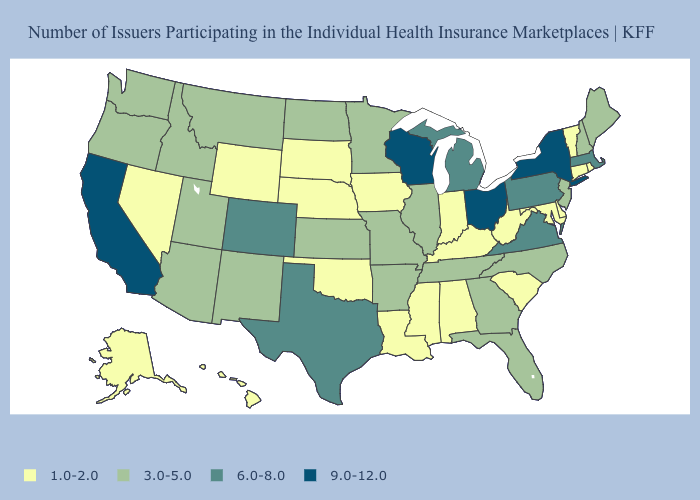What is the value of Missouri?
Concise answer only. 3.0-5.0. Among the states that border New Hampshire , does Massachusetts have the highest value?
Be succinct. Yes. How many symbols are there in the legend?
Answer briefly. 4. What is the highest value in the USA?
Write a very short answer. 9.0-12.0. What is the lowest value in the USA?
Write a very short answer. 1.0-2.0. How many symbols are there in the legend?
Give a very brief answer. 4. What is the value of South Carolina?
Quick response, please. 1.0-2.0. Does Maine have the highest value in the Northeast?
Be succinct. No. Which states have the lowest value in the USA?
Concise answer only. Alabama, Alaska, Connecticut, Delaware, Hawaii, Indiana, Iowa, Kentucky, Louisiana, Maryland, Mississippi, Nebraska, Nevada, Oklahoma, Rhode Island, South Carolina, South Dakota, Vermont, West Virginia, Wyoming. Does the first symbol in the legend represent the smallest category?
Write a very short answer. Yes. Among the states that border New Jersey , does New York have the highest value?
Keep it brief. Yes. Does Indiana have a lower value than Rhode Island?
Be succinct. No. What is the lowest value in the USA?
Keep it brief. 1.0-2.0. Does the first symbol in the legend represent the smallest category?
Concise answer only. Yes. Name the states that have a value in the range 9.0-12.0?
Keep it brief. California, New York, Ohio, Wisconsin. 